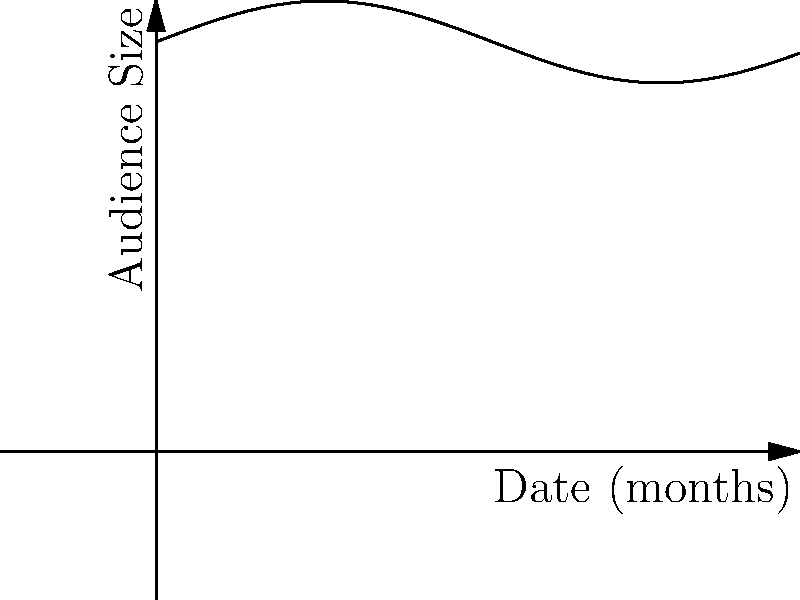The graph shows the audience size at your concerts over a 12-month period. At which point during this period is the rate of change in audience size the greatest, and what is the approximate value of this maximum rate of change? To find the point of greatest rate of change and its value, we need to follow these steps:

1) The given function appears to be of the form $f(x) = 5000 + 500\sin(x/2)$, where $x$ is in months and $f(x)$ is the audience size.

2) The rate of change is given by the derivative of this function:
   $f'(x) = 500 \cdot \frac{1}{2} \cos(x/2) = 250\cos(x/2)$

3) The maximum rate of change occurs where $\cos(x/2)$ is at its maximum, which is 1 or -1.

4) $\cos(x/2) = 1$ when $x/2 = 0, 2\pi, 4\pi, ...$
   $\cos(x/2) = -1$ when $x/2 = \pi, 3\pi, 5\pi, ...$

5) In the 12-month period (0 ≤ x ≤ 12), this occurs at:
   x = 0 (positive rate of change)
   x = 6 (negative rate of change)

6) The maximum absolute rate of change is:
   $|f'(x)| = |250\cos(x/2)| = 250$ audience members per month

7) This occurs at x = 0, where the rate is positive (increasing), and at x = 6, where the rate is negative (decreasing).
Answer: At 0 and 6 months; 250 audience members/month 